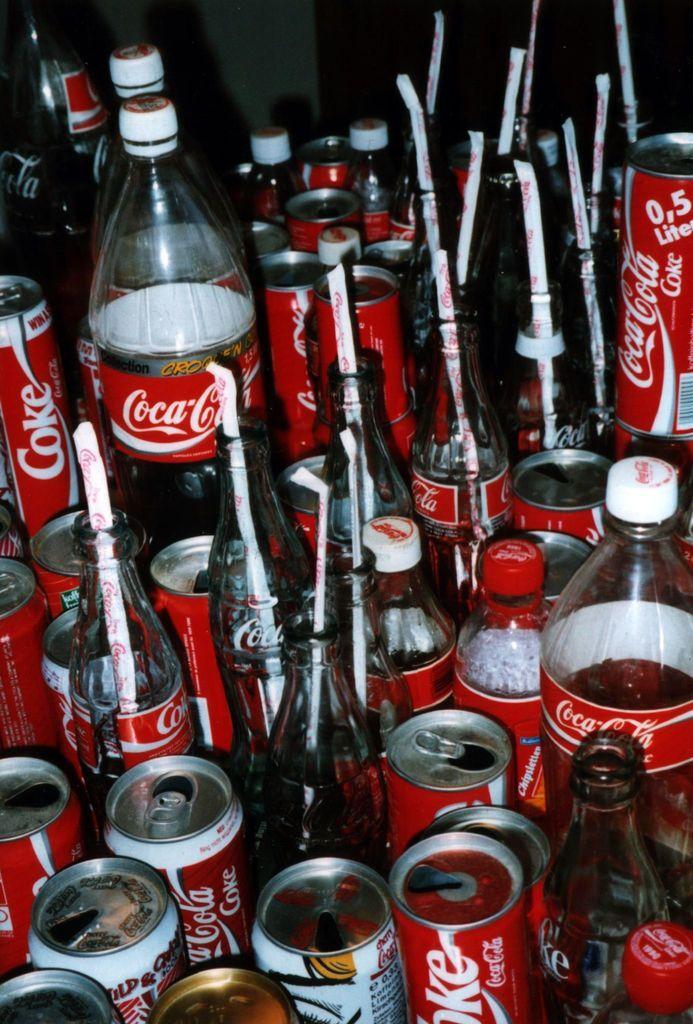How would you summarize this image in a sentence or two? In this picture there are many bottles and coke tins. 